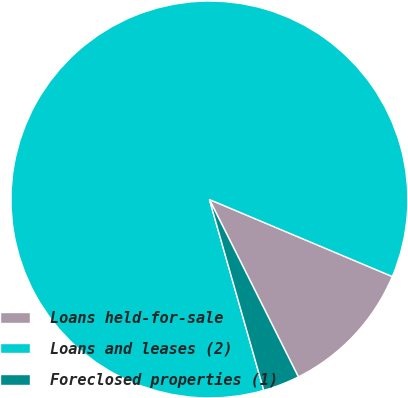<chart> <loc_0><loc_0><loc_500><loc_500><pie_chart><fcel>Loans held-for-sale<fcel>Loans and leases (2)<fcel>Foreclosed properties (1)<nl><fcel>11.26%<fcel>85.77%<fcel>2.98%<nl></chart> 